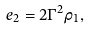Convert formula to latex. <formula><loc_0><loc_0><loc_500><loc_500>e _ { 2 } = 2 \Gamma ^ { 2 } \rho _ { 1 } ,</formula> 